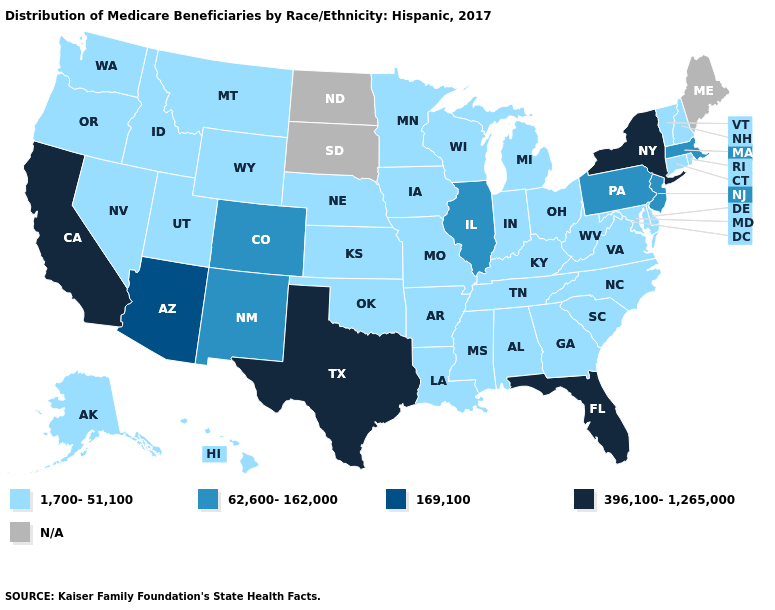Name the states that have a value in the range 1,700-51,100?
Short answer required. Alabama, Alaska, Arkansas, Connecticut, Delaware, Georgia, Hawaii, Idaho, Indiana, Iowa, Kansas, Kentucky, Louisiana, Maryland, Michigan, Minnesota, Mississippi, Missouri, Montana, Nebraska, Nevada, New Hampshire, North Carolina, Ohio, Oklahoma, Oregon, Rhode Island, South Carolina, Tennessee, Utah, Vermont, Virginia, Washington, West Virginia, Wisconsin, Wyoming. Name the states that have a value in the range 396,100-1,265,000?
Concise answer only. California, Florida, New York, Texas. Name the states that have a value in the range 62,600-162,000?
Keep it brief. Colorado, Illinois, Massachusetts, New Jersey, New Mexico, Pennsylvania. Does California have the highest value in the USA?
Write a very short answer. Yes. What is the value of Wyoming?
Keep it brief. 1,700-51,100. Name the states that have a value in the range 169,100?
Quick response, please. Arizona. Does Illinois have the lowest value in the USA?
Answer briefly. No. What is the lowest value in states that border Utah?
Give a very brief answer. 1,700-51,100. What is the highest value in the USA?
Quick response, please. 396,100-1,265,000. Name the states that have a value in the range 396,100-1,265,000?
Short answer required. California, Florida, New York, Texas. Which states have the lowest value in the USA?
Be succinct. Alabama, Alaska, Arkansas, Connecticut, Delaware, Georgia, Hawaii, Idaho, Indiana, Iowa, Kansas, Kentucky, Louisiana, Maryland, Michigan, Minnesota, Mississippi, Missouri, Montana, Nebraska, Nevada, New Hampshire, North Carolina, Ohio, Oklahoma, Oregon, Rhode Island, South Carolina, Tennessee, Utah, Vermont, Virginia, Washington, West Virginia, Wisconsin, Wyoming. Among the states that border Georgia , does Tennessee have the highest value?
Be succinct. No. Name the states that have a value in the range 396,100-1,265,000?
Keep it brief. California, Florida, New York, Texas. Name the states that have a value in the range N/A?
Quick response, please. Maine, North Dakota, South Dakota. 